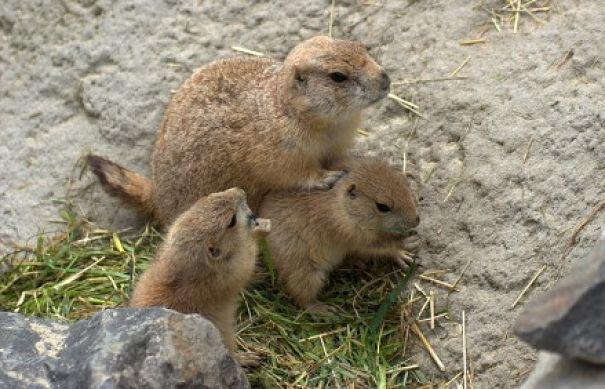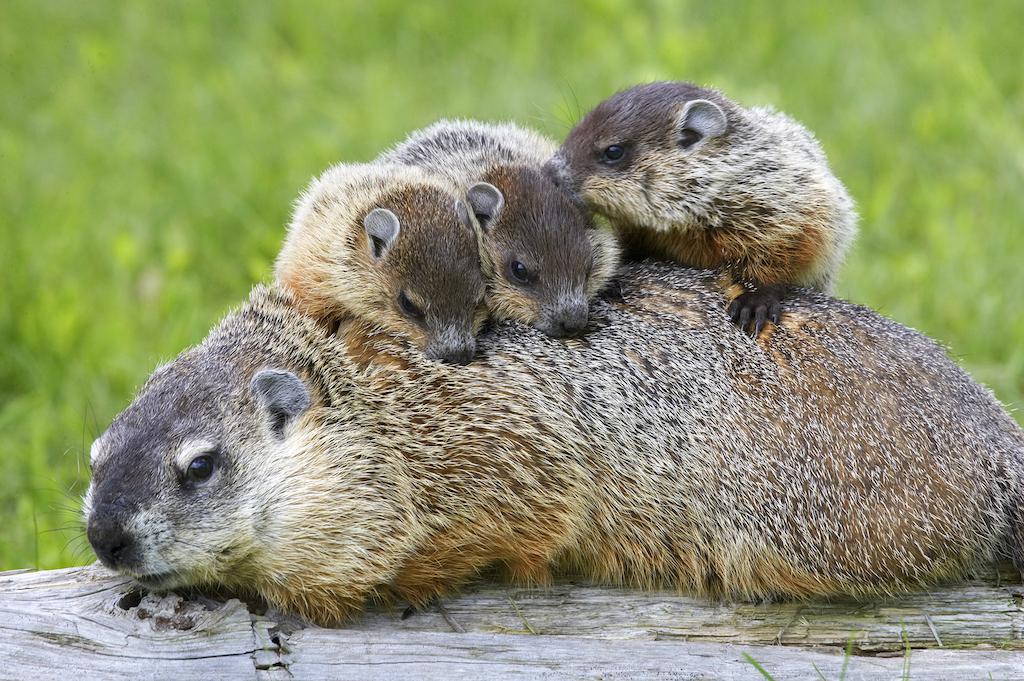The first image is the image on the left, the second image is the image on the right. Given the left and right images, does the statement "The left image includes a right-facing marmot with its front paws propped up on something." hold true? Answer yes or no. Yes. 